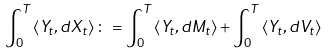Convert formula to latex. <formula><loc_0><loc_0><loc_500><loc_500>\int _ { 0 } ^ { T } \left \langle Y _ { t } , d X _ { t } \right \rangle \colon = \int _ { 0 } ^ { T } \left \langle Y _ { t } , d M _ { t } \right \rangle + \int _ { 0 } ^ { T } \left \langle Y _ { t } , d V _ { t } \right \rangle</formula> 